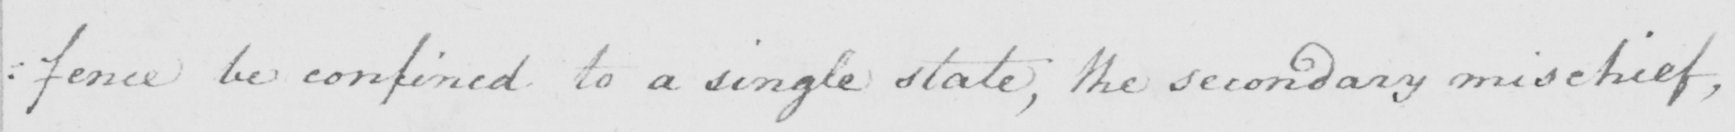Please provide the text content of this handwritten line. :fence be confined to a single state, the secondary mischief, 